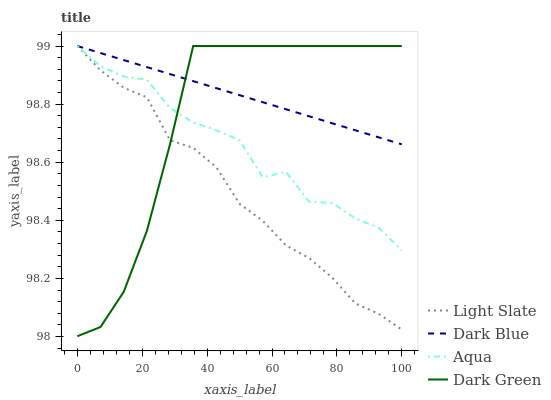Does Aqua have the minimum area under the curve?
Answer yes or no. No. Does Aqua have the maximum area under the curve?
Answer yes or no. No. Is Aqua the smoothest?
Answer yes or no. No. Is Dark Blue the roughest?
Answer yes or no. No. Does Aqua have the lowest value?
Answer yes or no. No. 